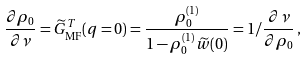<formula> <loc_0><loc_0><loc_500><loc_500>\frac { \partial \rho _ { 0 } } { \partial \nu } = \widetilde { G } _ { \text {MF} } ^ { T } ( q = 0 ) = \frac { \rho _ { 0 } ^ { ( 1 ) } } { 1 - \rho _ { 0 } ^ { ( 1 ) } \widetilde { w } ( 0 ) } = 1 / \frac { \partial \nu } { \partial \rho _ { 0 } } \, ,</formula> 